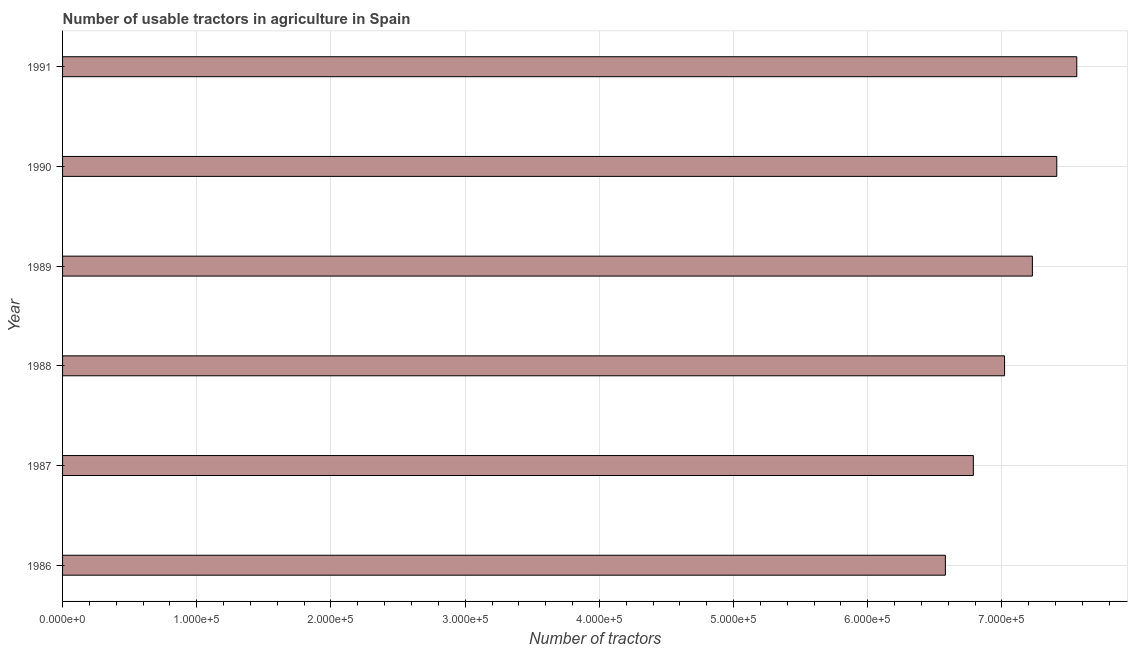What is the title of the graph?
Your answer should be compact. Number of usable tractors in agriculture in Spain. What is the label or title of the X-axis?
Provide a succinct answer. Number of tractors. What is the number of tractors in 1986?
Keep it short and to the point. 6.58e+05. Across all years, what is the maximum number of tractors?
Provide a short and direct response. 7.56e+05. Across all years, what is the minimum number of tractors?
Offer a very short reply. 6.58e+05. In which year was the number of tractors maximum?
Provide a succinct answer. 1991. What is the sum of the number of tractors?
Your response must be concise. 4.26e+06. What is the difference between the number of tractors in 1987 and 1989?
Make the answer very short. -4.40e+04. What is the average number of tractors per year?
Give a very brief answer. 7.10e+05. What is the median number of tractors?
Keep it short and to the point. 7.12e+05. In how many years, is the number of tractors greater than 160000 ?
Keep it short and to the point. 6. Do a majority of the years between 1990 and 1987 (inclusive) have number of tractors greater than 140000 ?
Provide a short and direct response. Yes. Is the number of tractors in 1987 less than that in 1989?
Offer a terse response. Yes. Is the difference between the number of tractors in 1986 and 1989 greater than the difference between any two years?
Your response must be concise. No. What is the difference between the highest and the second highest number of tractors?
Provide a short and direct response. 1.49e+04. What is the difference between the highest and the lowest number of tractors?
Offer a very short reply. 9.79e+04. In how many years, is the number of tractors greater than the average number of tractors taken over all years?
Offer a terse response. 3. How many bars are there?
Your answer should be very brief. 6. What is the Number of tractors of 1986?
Keep it short and to the point. 6.58e+05. What is the Number of tractors in 1987?
Give a very brief answer. 6.79e+05. What is the Number of tractors in 1988?
Offer a terse response. 7.02e+05. What is the Number of tractors of 1989?
Ensure brevity in your answer.  7.23e+05. What is the Number of tractors in 1990?
Provide a short and direct response. 7.41e+05. What is the Number of tractors of 1991?
Offer a terse response. 7.56e+05. What is the difference between the Number of tractors in 1986 and 1987?
Give a very brief answer. -2.09e+04. What is the difference between the Number of tractors in 1986 and 1988?
Your answer should be very brief. -4.41e+04. What is the difference between the Number of tractors in 1986 and 1989?
Your response must be concise. -6.48e+04. What is the difference between the Number of tractors in 1986 and 1990?
Provide a short and direct response. -8.30e+04. What is the difference between the Number of tractors in 1986 and 1991?
Provide a short and direct response. -9.79e+04. What is the difference between the Number of tractors in 1987 and 1988?
Give a very brief answer. -2.32e+04. What is the difference between the Number of tractors in 1987 and 1989?
Keep it short and to the point. -4.40e+04. What is the difference between the Number of tractors in 1987 and 1990?
Keep it short and to the point. -6.22e+04. What is the difference between the Number of tractors in 1987 and 1991?
Offer a terse response. -7.71e+04. What is the difference between the Number of tractors in 1988 and 1989?
Your answer should be very brief. -2.07e+04. What is the difference between the Number of tractors in 1988 and 1990?
Offer a very short reply. -3.89e+04. What is the difference between the Number of tractors in 1988 and 1991?
Your answer should be very brief. -5.38e+04. What is the difference between the Number of tractors in 1989 and 1990?
Give a very brief answer. -1.82e+04. What is the difference between the Number of tractors in 1989 and 1991?
Provide a succinct answer. -3.31e+04. What is the difference between the Number of tractors in 1990 and 1991?
Provide a succinct answer. -1.49e+04. What is the ratio of the Number of tractors in 1986 to that in 1987?
Your answer should be very brief. 0.97. What is the ratio of the Number of tractors in 1986 to that in 1988?
Keep it short and to the point. 0.94. What is the ratio of the Number of tractors in 1986 to that in 1989?
Your response must be concise. 0.91. What is the ratio of the Number of tractors in 1986 to that in 1990?
Offer a terse response. 0.89. What is the ratio of the Number of tractors in 1986 to that in 1991?
Provide a short and direct response. 0.87. What is the ratio of the Number of tractors in 1987 to that in 1989?
Give a very brief answer. 0.94. What is the ratio of the Number of tractors in 1987 to that in 1990?
Make the answer very short. 0.92. What is the ratio of the Number of tractors in 1987 to that in 1991?
Keep it short and to the point. 0.9. What is the ratio of the Number of tractors in 1988 to that in 1989?
Provide a short and direct response. 0.97. What is the ratio of the Number of tractors in 1988 to that in 1990?
Your response must be concise. 0.95. What is the ratio of the Number of tractors in 1988 to that in 1991?
Make the answer very short. 0.93. What is the ratio of the Number of tractors in 1989 to that in 1990?
Keep it short and to the point. 0.97. What is the ratio of the Number of tractors in 1989 to that in 1991?
Offer a terse response. 0.96. 